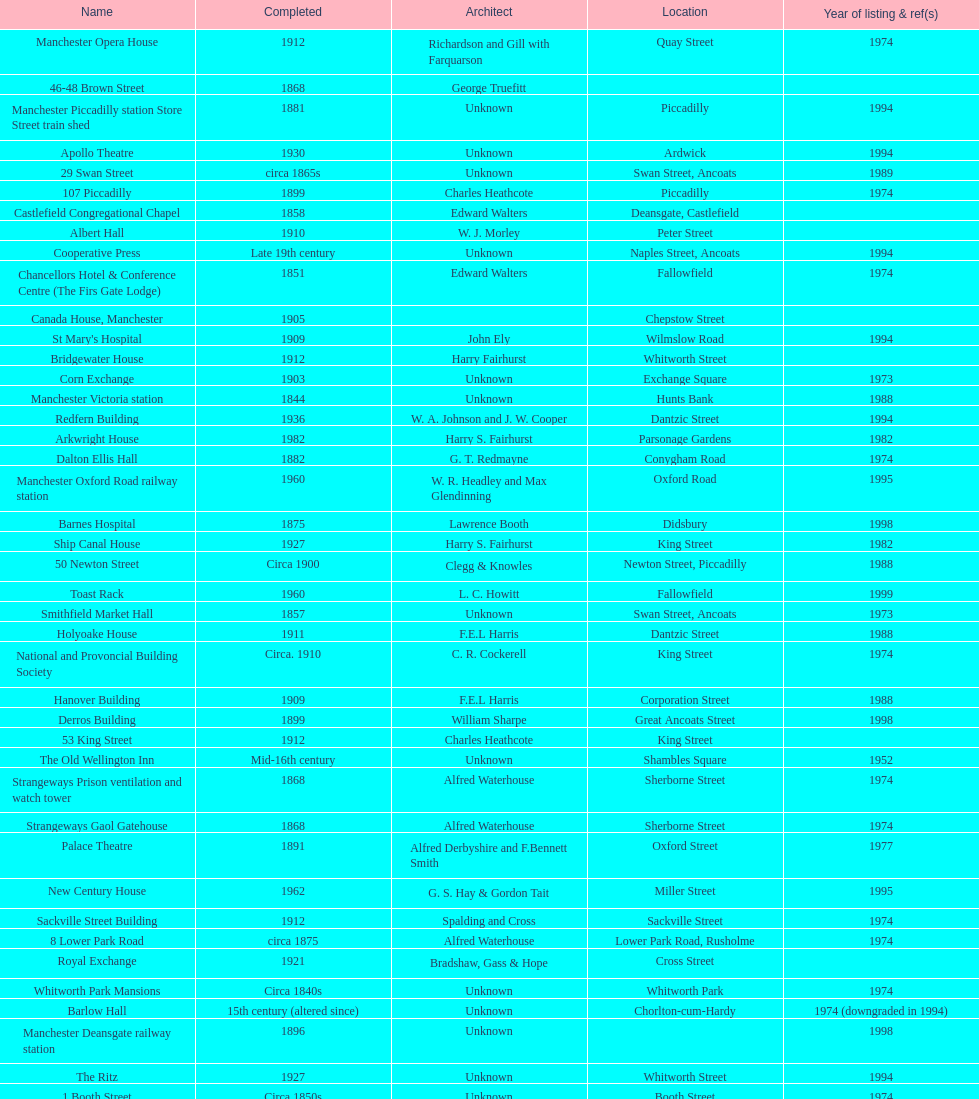Which year has the most buildings listed? 1974. 